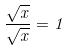<formula> <loc_0><loc_0><loc_500><loc_500>\frac { \sqrt { x } } { \sqrt { x } } = 1</formula> 